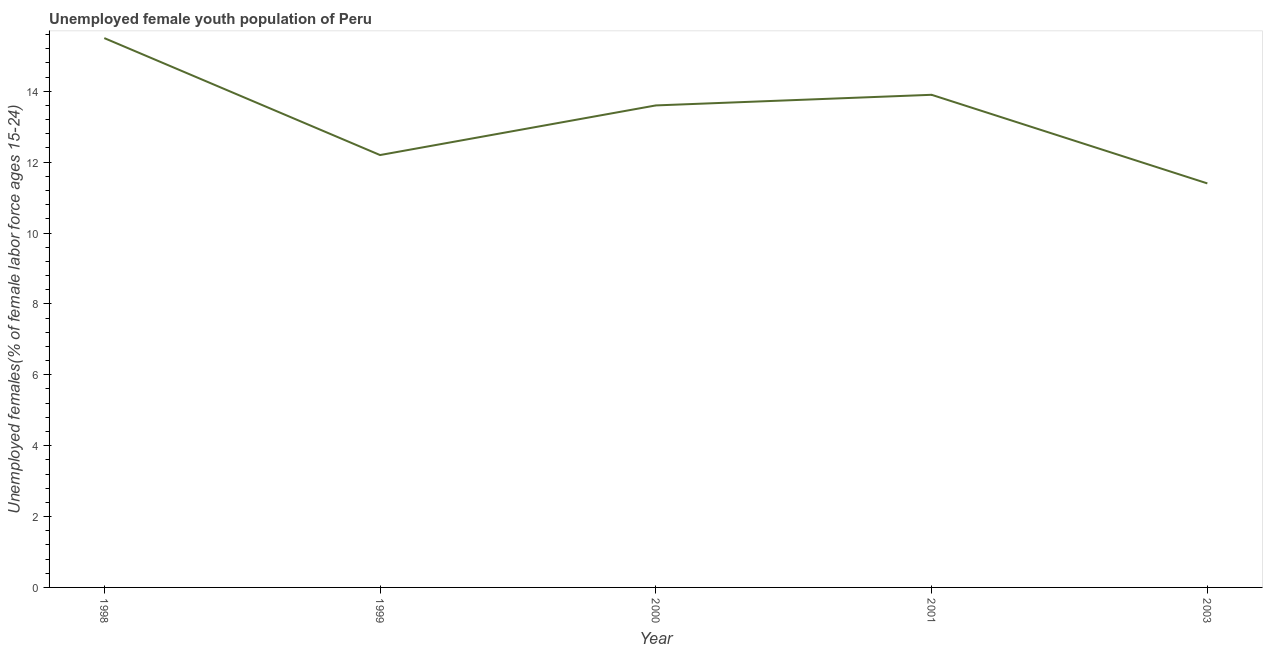What is the unemployed female youth in 2003?
Provide a short and direct response. 11.4. Across all years, what is the minimum unemployed female youth?
Your answer should be very brief. 11.4. In which year was the unemployed female youth minimum?
Your response must be concise. 2003. What is the sum of the unemployed female youth?
Ensure brevity in your answer.  66.6. What is the average unemployed female youth per year?
Your response must be concise. 13.32. What is the median unemployed female youth?
Provide a short and direct response. 13.6. In how many years, is the unemployed female youth greater than 13.6 %?
Provide a short and direct response. 3. What is the ratio of the unemployed female youth in 1999 to that in 2000?
Your answer should be very brief. 0.9. Is the unemployed female youth in 1998 less than that in 2001?
Your answer should be very brief. No. Is the difference between the unemployed female youth in 2000 and 2001 greater than the difference between any two years?
Keep it short and to the point. No. What is the difference between the highest and the second highest unemployed female youth?
Make the answer very short. 1.6. Is the sum of the unemployed female youth in 1999 and 2003 greater than the maximum unemployed female youth across all years?
Give a very brief answer. Yes. What is the difference between the highest and the lowest unemployed female youth?
Give a very brief answer. 4.1. In how many years, is the unemployed female youth greater than the average unemployed female youth taken over all years?
Ensure brevity in your answer.  3. Does the unemployed female youth monotonically increase over the years?
Your answer should be compact. No. Are the values on the major ticks of Y-axis written in scientific E-notation?
Offer a terse response. No. Does the graph contain any zero values?
Provide a succinct answer. No. Does the graph contain grids?
Ensure brevity in your answer.  No. What is the title of the graph?
Offer a very short reply. Unemployed female youth population of Peru. What is the label or title of the Y-axis?
Give a very brief answer. Unemployed females(% of female labor force ages 15-24). What is the Unemployed females(% of female labor force ages 15-24) of 1999?
Ensure brevity in your answer.  12.2. What is the Unemployed females(% of female labor force ages 15-24) of 2000?
Ensure brevity in your answer.  13.6. What is the Unemployed females(% of female labor force ages 15-24) in 2001?
Your answer should be compact. 13.9. What is the Unemployed females(% of female labor force ages 15-24) in 2003?
Your answer should be compact. 11.4. What is the difference between the Unemployed females(% of female labor force ages 15-24) in 1998 and 2000?
Your response must be concise. 1.9. What is the difference between the Unemployed females(% of female labor force ages 15-24) in 1998 and 2001?
Ensure brevity in your answer.  1.6. What is the difference between the Unemployed females(% of female labor force ages 15-24) in 1999 and 2000?
Provide a short and direct response. -1.4. What is the difference between the Unemployed females(% of female labor force ages 15-24) in 1999 and 2001?
Give a very brief answer. -1.7. What is the difference between the Unemployed females(% of female labor force ages 15-24) in 2000 and 2001?
Your response must be concise. -0.3. What is the difference between the Unemployed females(% of female labor force ages 15-24) in 2001 and 2003?
Provide a short and direct response. 2.5. What is the ratio of the Unemployed females(% of female labor force ages 15-24) in 1998 to that in 1999?
Offer a very short reply. 1.27. What is the ratio of the Unemployed females(% of female labor force ages 15-24) in 1998 to that in 2000?
Your answer should be very brief. 1.14. What is the ratio of the Unemployed females(% of female labor force ages 15-24) in 1998 to that in 2001?
Your answer should be very brief. 1.11. What is the ratio of the Unemployed females(% of female labor force ages 15-24) in 1998 to that in 2003?
Provide a short and direct response. 1.36. What is the ratio of the Unemployed females(% of female labor force ages 15-24) in 1999 to that in 2000?
Your response must be concise. 0.9. What is the ratio of the Unemployed females(% of female labor force ages 15-24) in 1999 to that in 2001?
Your response must be concise. 0.88. What is the ratio of the Unemployed females(% of female labor force ages 15-24) in 1999 to that in 2003?
Your answer should be compact. 1.07. What is the ratio of the Unemployed females(% of female labor force ages 15-24) in 2000 to that in 2003?
Provide a succinct answer. 1.19. What is the ratio of the Unemployed females(% of female labor force ages 15-24) in 2001 to that in 2003?
Give a very brief answer. 1.22. 